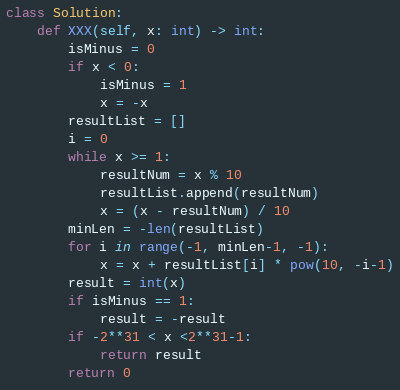<code> <loc_0><loc_0><loc_500><loc_500><_Python_>class Solution:
    def XXX(self, x: int) -> int:
        isMinus = 0
        if x < 0:
            isMinus = 1
            x = -x
        resultList = []
        i = 0
        while x >= 1:
            resultNum = x % 10
            resultList.append(resultNum)
            x = (x - resultNum) / 10
        minLen = -len(resultList)
        for i in range(-1, minLen-1, -1):
            x = x + resultList[i] * pow(10, -i-1)
        result = int(x)
        if isMinus == 1:
            result = -result
        if -2**31 < x <2**31-1:
            return result
        return 0





</code> 